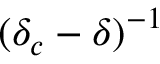<formula> <loc_0><loc_0><loc_500><loc_500>( \delta _ { c } - \delta ) ^ { - 1 }</formula> 